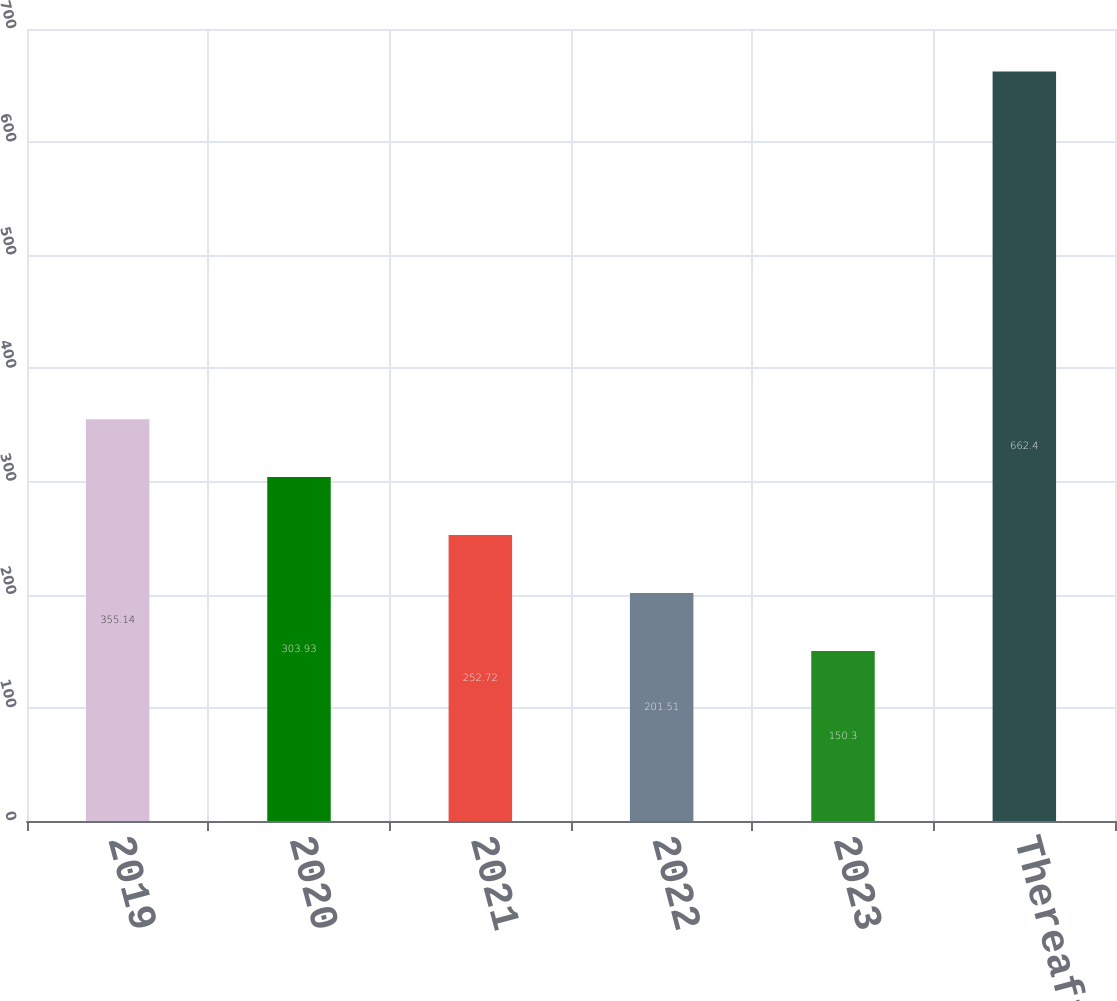Convert chart to OTSL. <chart><loc_0><loc_0><loc_500><loc_500><bar_chart><fcel>2019<fcel>2020<fcel>2021<fcel>2022<fcel>2023<fcel>Thereafter<nl><fcel>355.14<fcel>303.93<fcel>252.72<fcel>201.51<fcel>150.3<fcel>662.4<nl></chart> 